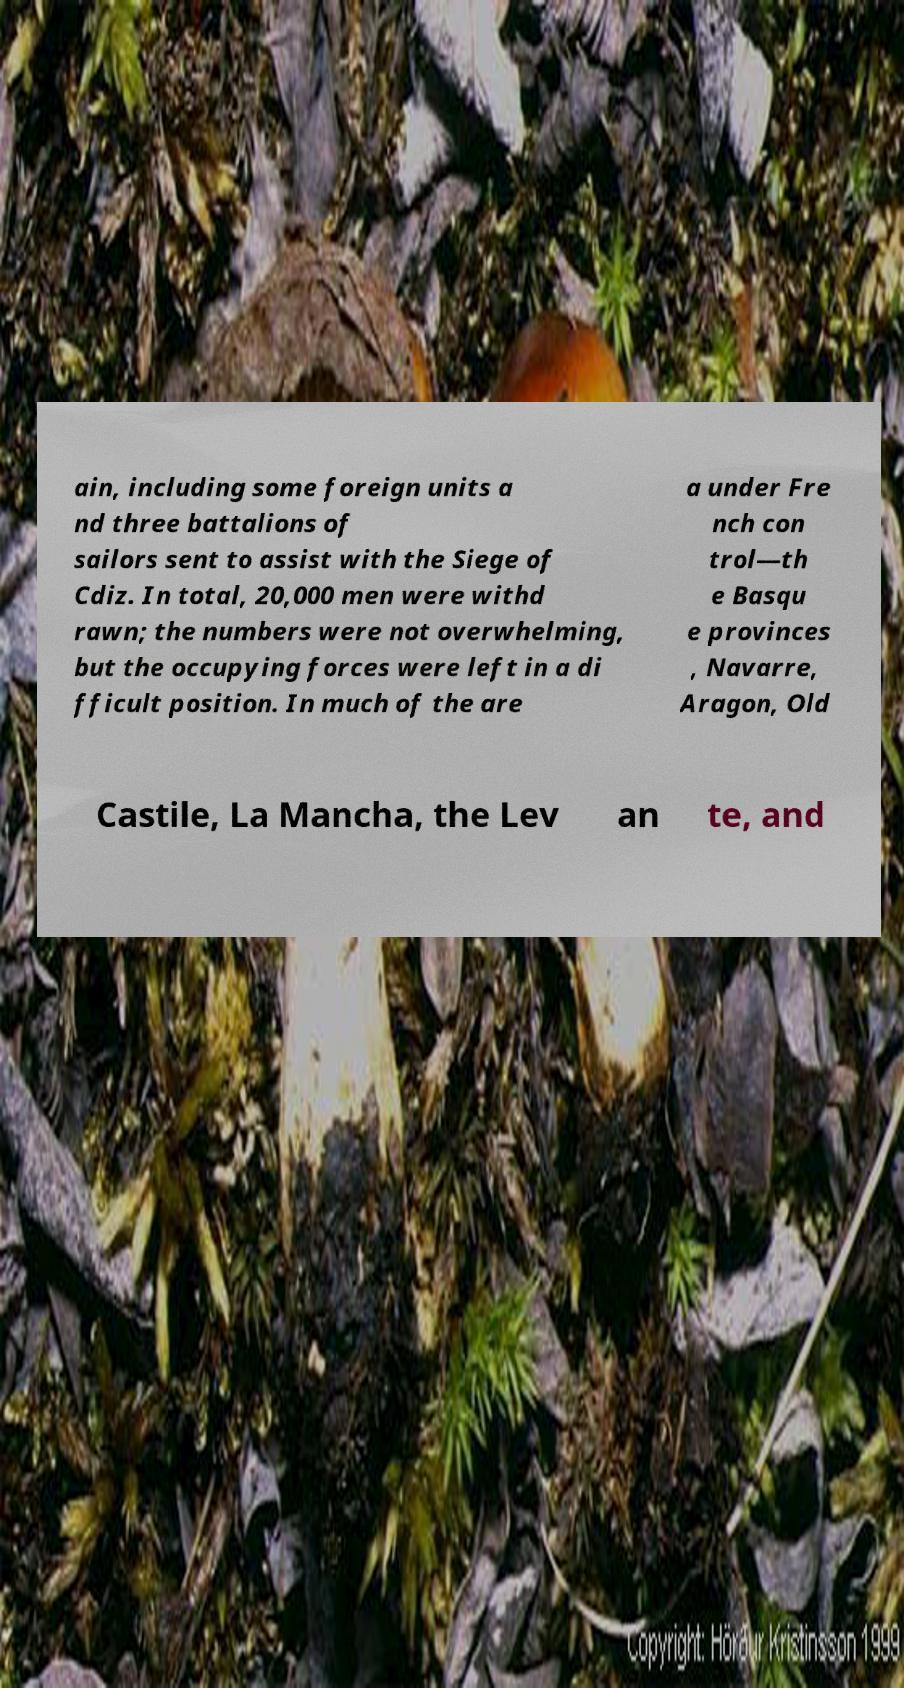Could you extract and type out the text from this image? ain, including some foreign units a nd three battalions of sailors sent to assist with the Siege of Cdiz. In total, 20,000 men were withd rawn; the numbers were not overwhelming, but the occupying forces were left in a di fficult position. In much of the are a under Fre nch con trol—th e Basqu e provinces , Navarre, Aragon, Old Castile, La Mancha, the Lev an te, and 